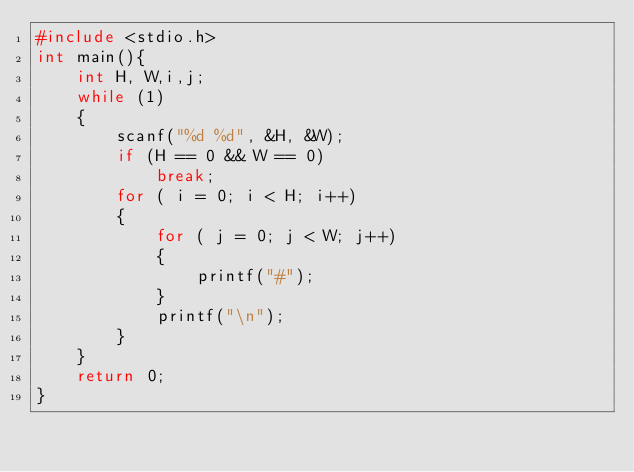<code> <loc_0><loc_0><loc_500><loc_500><_C_>#include <stdio.h>
int main(){
	int H, W,i,j;
	while (1)
	{
		scanf("%d %d", &H, &W);
		if (H == 0 && W == 0)
			break;
		for ( i = 0; i < H; i++)
		{
			for ( j = 0; j < W; j++)
			{
				printf("#");
			}
			printf("\n");
		}
	}
	return 0;
}</code> 